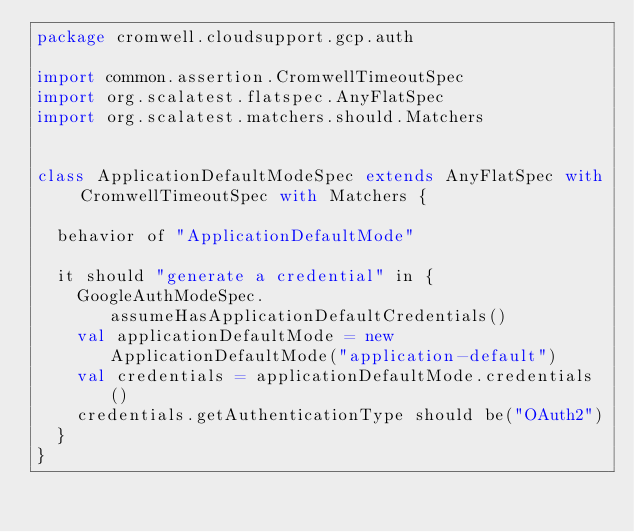Convert code to text. <code><loc_0><loc_0><loc_500><loc_500><_Scala_>package cromwell.cloudsupport.gcp.auth

import common.assertion.CromwellTimeoutSpec
import org.scalatest.flatspec.AnyFlatSpec
import org.scalatest.matchers.should.Matchers


class ApplicationDefaultModeSpec extends AnyFlatSpec with CromwellTimeoutSpec with Matchers {

  behavior of "ApplicationDefaultMode"

  it should "generate a credential" in {
    GoogleAuthModeSpec.assumeHasApplicationDefaultCredentials()
    val applicationDefaultMode = new ApplicationDefaultMode("application-default")
    val credentials = applicationDefaultMode.credentials()
    credentials.getAuthenticationType should be("OAuth2")
  }
}
</code> 